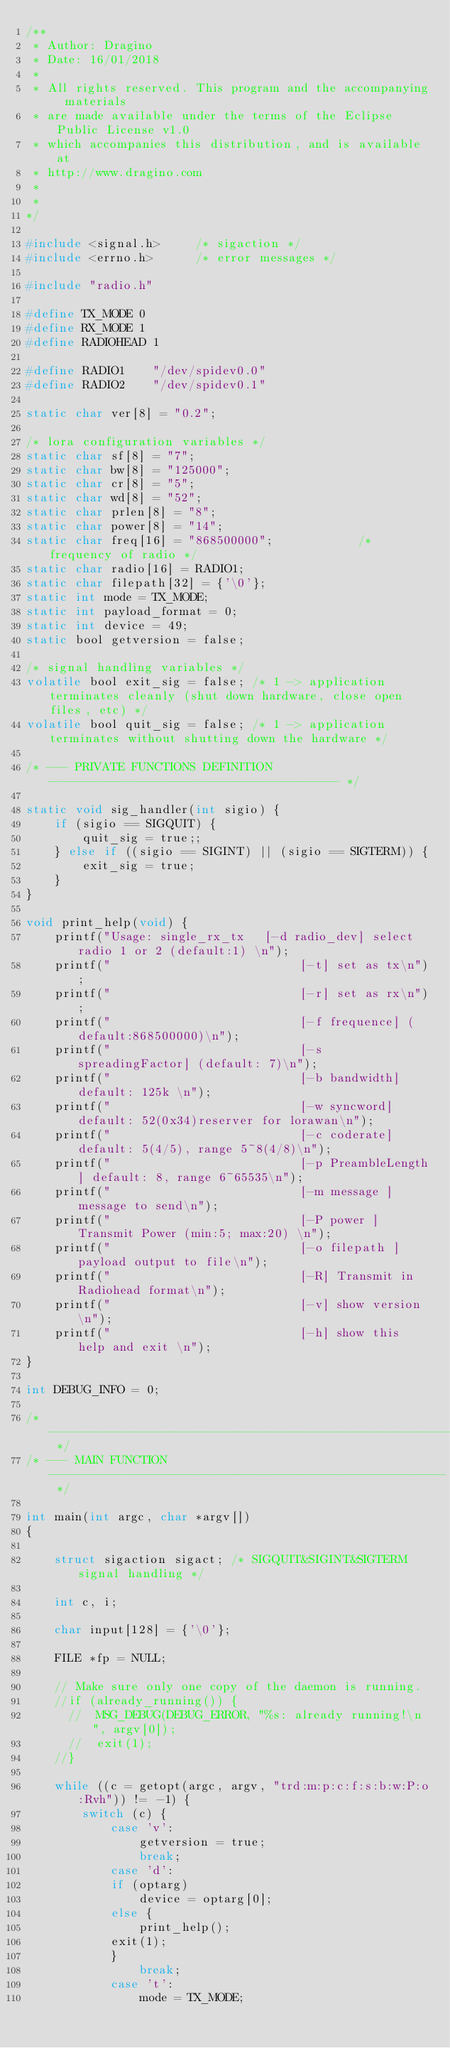<code> <loc_0><loc_0><loc_500><loc_500><_C_>/**
 * Author: Dragino 
 * Date: 16/01/2018
 * 
 * All rights reserved. This program and the accompanying materials
 * are made available under the terms of the Eclipse Public License v1.0
 * which accompanies this distribution, and is available at
 * http://www.dragino.com
 *
 * 
*/

#include <signal.h>		/* sigaction */
#include <errno.h>		/* error messages */

#include "radio.h"

#define TX_MODE 0
#define RX_MODE 1
#define RADIOHEAD 1

#define RADIO1    "/dev/spidev0.0"
#define RADIO2    "/dev/spidev0.1"

static char ver[8] = "0.2";

/* lora configuration variables */
static char sf[8] = "7";
static char bw[8] = "125000";
static char cr[8] = "5";
static char wd[8] = "52";
static char prlen[8] = "8";
static char power[8] = "14";
static char freq[16] = "868500000";            /* frequency of radio */
static char radio[16] = RADIO1;
static char filepath[32] = {'\0'};
static int mode = TX_MODE;
static int payload_format = 0; 
static int device = 49;
static bool getversion = false;

/* signal handling variables */
volatile bool exit_sig = false; /* 1 -> application terminates cleanly (shut down hardware, close open files, etc) */
volatile bool quit_sig = false; /* 1 -> application terminates without shutting down the hardware */

/* --- PRIVATE FUNCTIONS DEFINITION ----------------------------------------- */

static void sig_handler(int sigio) {
    if (sigio == SIGQUIT) {
	    quit_sig = true;;
    } else if ((sigio == SIGINT) || (sigio == SIGTERM)) {
	    exit_sig = true;
    }
}

void print_help(void) {
    printf("Usage: single_rx_tx   [-d radio_dev] select radio 1 or 2 (default:1) \n");
    printf("                           [-t] set as tx\n");
    printf("                           [-r] set as rx\n");
    printf("                           [-f frequence] (default:868500000)\n");
    printf("                           [-s spreadingFactor] (default: 7)\n");
    printf("                           [-b bandwidth] default: 125k \n");
    printf("                           [-w syncword] default: 52(0x34)reserver for lorawan\n");
    printf("                           [-c coderate] default: 5(4/5), range 5~8(4/8)\n");
    printf("                           [-p PreambleLength] default: 8, range 6~65535\n");
    printf("                           [-m message ]  message to send\n");
    printf("                           [-P power ] Transmit Power (min:5; max:20) \n");
    printf("                           [-o filepath ] payload output to file\n");
    printf("                           [-R] Transmit in Radiohead format\n");
    printf("                           [-v] show version \n");
    printf("                           [-h] show this help and exit \n");
}

int DEBUG_INFO = 0;       

/* -------------------------------------------------------------------------- */
/* --- MAIN FUNCTION -------------------------------------------------------- */

int main(int argc, char *argv[])
{

    struct sigaction sigact; /* SIGQUIT&SIGINT&SIGTERM signal handling */
	
    int c, i;

    char input[128] = {'\0'};

    FILE *fp = NULL;

    // Make sure only one copy of the daemon is running.
    //if (already_running()) {
      //  MSG_DEBUG(DEBUG_ERROR, "%s: already running!\n", argv[0]);
      //  exit(1);
    //}

    while ((c = getopt(argc, argv, "trd:m:p:c:f:s:b:w:P:o:Rvh")) != -1) {
        switch (c) {
            case 'v':
                getversion = true;
                break;
            case 'd':
	        if (optarg)
	            device = optarg[0];
	        else {
	            print_help();
		    exit(1);
	        }
                break;
            case 't':
                mode = TX_MODE;</code> 